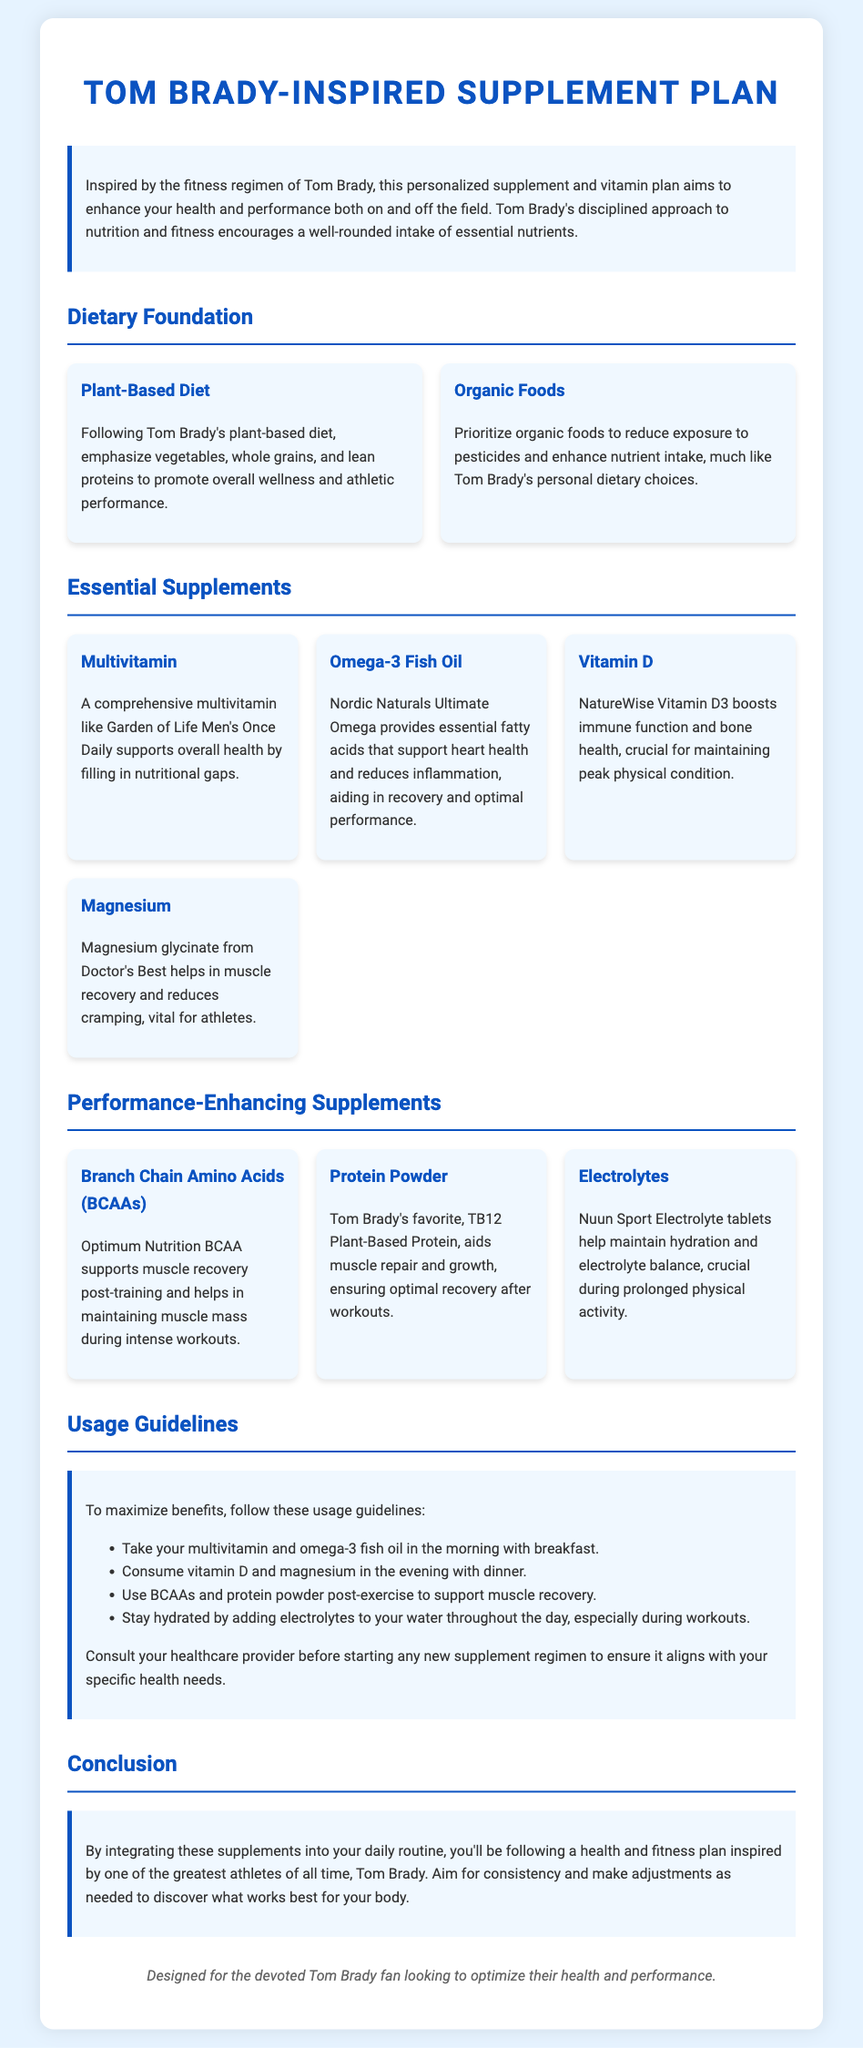What is the title of the document? The title is prominently displayed at the top of the document, clearly indicating the subject matter.
Answer: Tom Brady-Inspired Supplement Plan Who inspires the supplement plan? The document specifies the name of the athlete whose approach influences this plan.
Answer: Tom Brady What type of diet is emphasized? The document outlines a specific dietary choice that is central to the overall health strategy.
Answer: Plant-Based Diet Which multivitamin is recommended? A specific brand of multivitamin is mentioned as a vital supplement in the plan.
Answer: Garden of Life Men's Once Daily When should magnesium be taken? The recommendations in the usage guidelines specify the time to take this supplement for optimal benefits.
Answer: In the evening with dinner What benefit do omega-3 fish oils provide? The document states a particular health benefit associated with omega-3 fish oil intake.
Answer: Supports heart health and reduces inflammation What is Tom Brady's favorite protein powder? The document explicitly mentions the favorite choice of protein supplement linked to Tom Brady.
Answer: TB12 Plant-Based Protein What should be consumed post-exercise? The guidelines specify which supplements are to be taken after workouts for recovery.
Answer: BCAAs and protein powder How should hydration be maintained during workouts? The document describes a method for ensuring proper hydration while exercising.
Answer: Adding electrolytes to water 